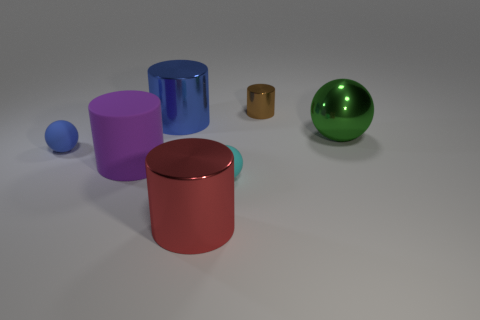There is a big red metal cylinder that is left of the small thing that is behind the green metallic object; what number of shiny cylinders are left of it? To the left of the small, unidentifiable object which is located behind the green metallic sphere, there stands only one large, shiny red cylinder. 